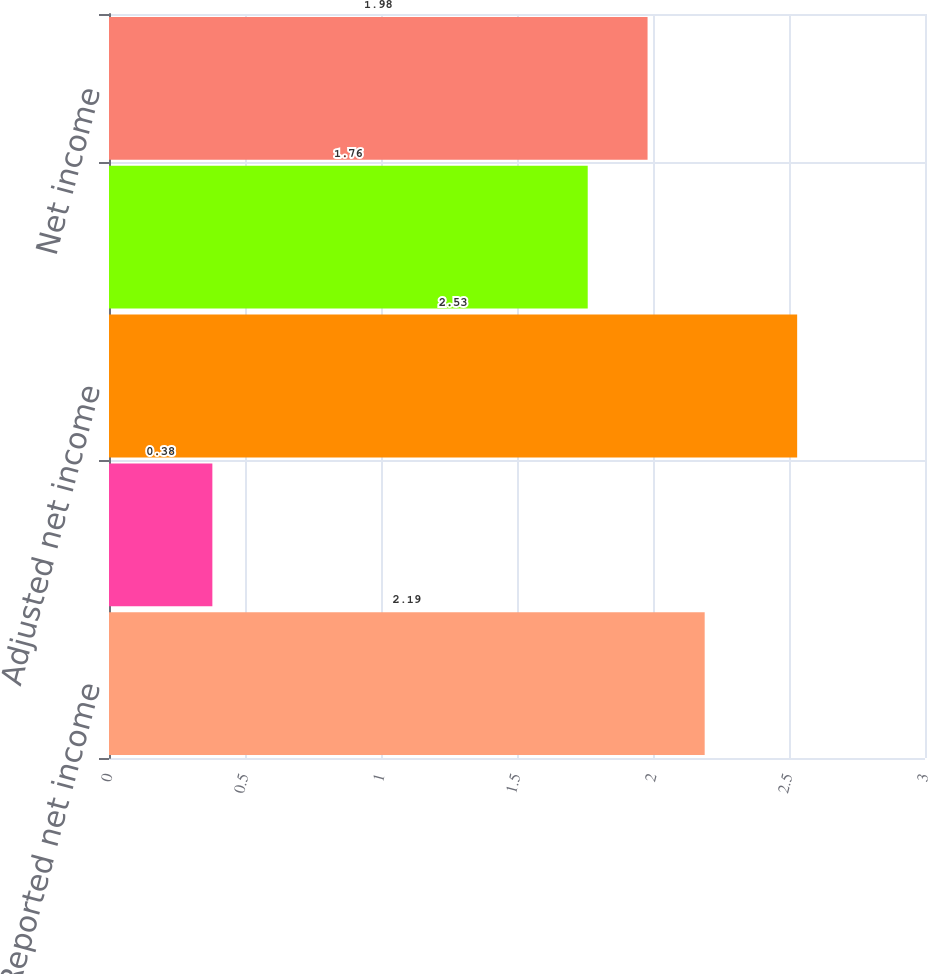Convert chart. <chart><loc_0><loc_0><loc_500><loc_500><bar_chart><fcel>Reported net income<fcel>Add Goodwill amortization<fcel>Adjusted net income<fcel>Income before cumulative<fcel>Net income<nl><fcel>2.19<fcel>0.38<fcel>2.53<fcel>1.76<fcel>1.98<nl></chart> 